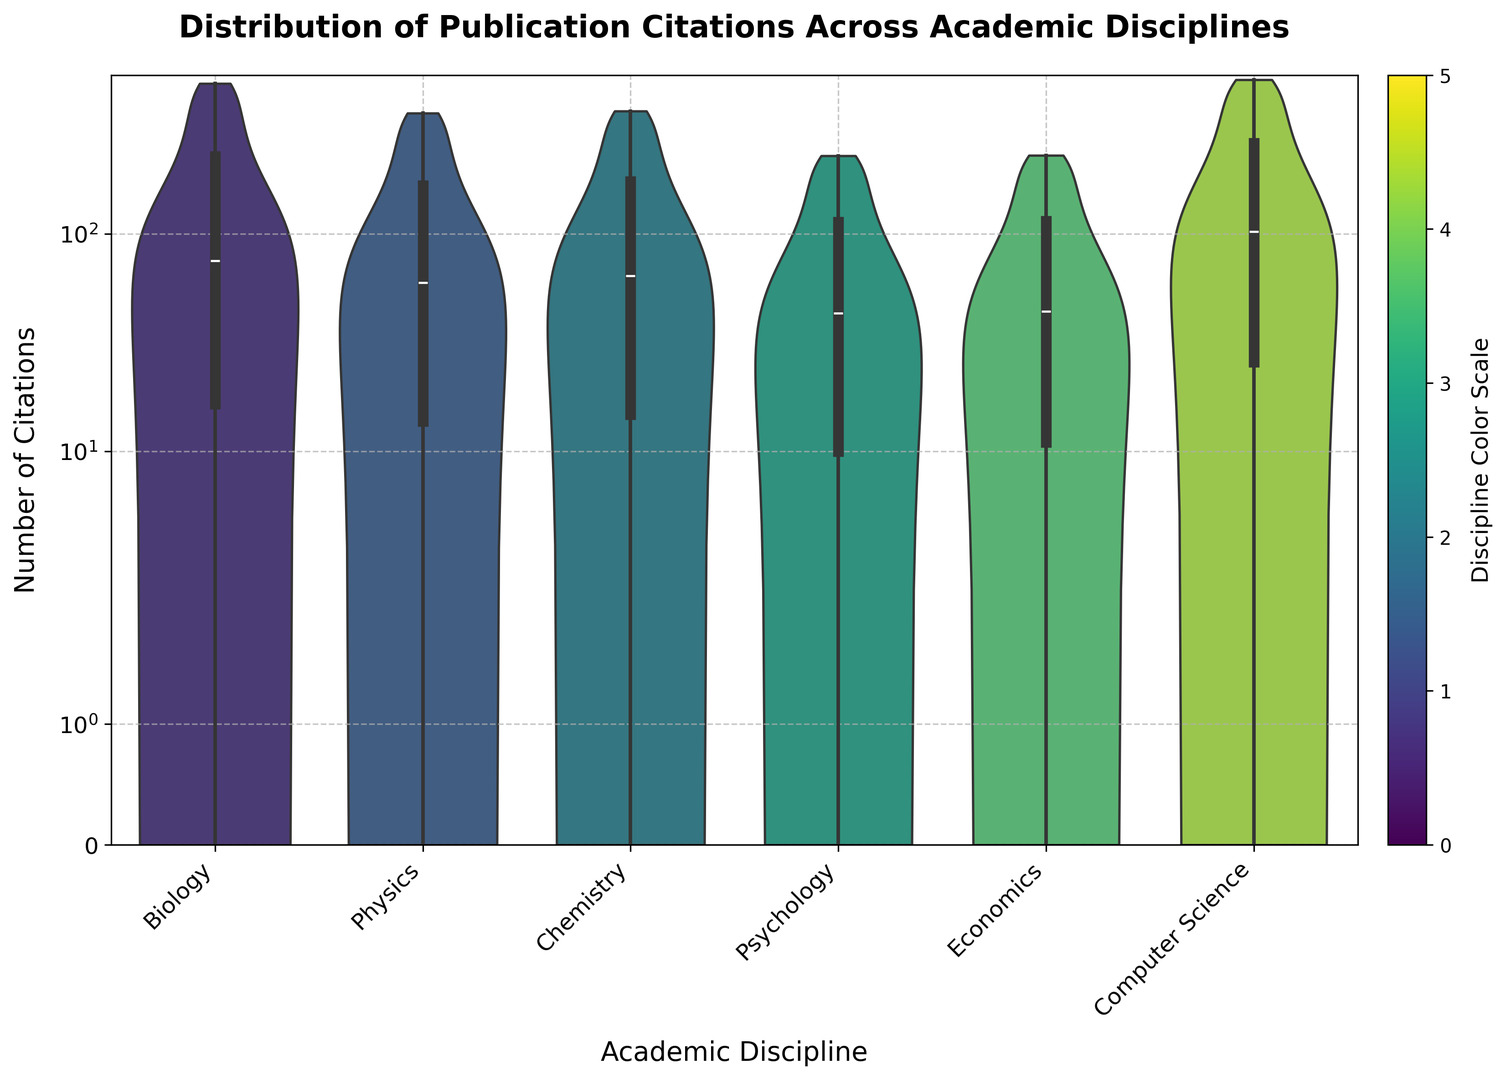What is the median number of citations in the Psychology discipline? The median of a dataset is the middle value when it is ordered. In the violin plot for Psychology, the middle value can be read from the width of the plot at the point where it is the narrowest in the middle of the vertical axis.
Answer: 38 Which discipline has the highest number of citations? To find the discipline with the highest citations, we look for the column in the violin plot that extends highest on the y-axis.
Answer: Computer Science What can you say about the distribution of citations in Economics compared to Chemistry? Comparing the violin plots for Economics and Chemistry, we observe that the plot for Economics is narrower and more evenly distributed, while the plot for Chemistry has a wider spread with more variation in the number of citations. This indicates that citations are more consistent in Economics and more varied in Chemistry.
Answer: Economics is more consistent, Chemistry is more varied Which two disciplines have the most similar distribution of citations? By visually inspecting the width and shape of the violin plots, we find the plots for Economics and Psychology have a similar shape and spread, indicating a similar distribution of citation numbers.
Answer: Economics and Psychology What is the range of citations for Biology? The range is the difference between the maximum and minimum values. In the violin plot for Biology, the plot extends from 0 to just below 500 on the y-axis, so 490 is the highest number of citations. The lowest is 0. Therefore, the range is 490 - 0.
Answer: 490 Is there any discipline that shows a significant clustering of citations around the lower end of the scale? By observing the violin plots, Psychology has a significant clustering at the lower end of the y-axis, indicating many publications with low citation counts. This can be deduced from the density of the plot near the bottom.
Answer: Psychology Which discipline appears to have the most evenly distributed citations? From the violin plots, Physics has a more even distribution with a relatively uniform spread of citation counts, indicating a consistent number of citations across publications without significant peaks or clusters.
Answer: Physics How does the citation distribution in Computer Science contrast with Biology? The plot for Computer Science shows a wide spread extending up to 510 citations, indicating some publications with exceptionally high citations compared to Biology, which also has a broad distribution but slightly lower in the highest citations count.
Answer: Computer Science has higher citation extremes Analyzing the median values, which discipline ranks second in citation counts? By looking at the median points in the violin plots, Chemistry has its median closer to the higher end compared to others excluding the very top rank, which is Computer Science.
Answer: Chemistry 